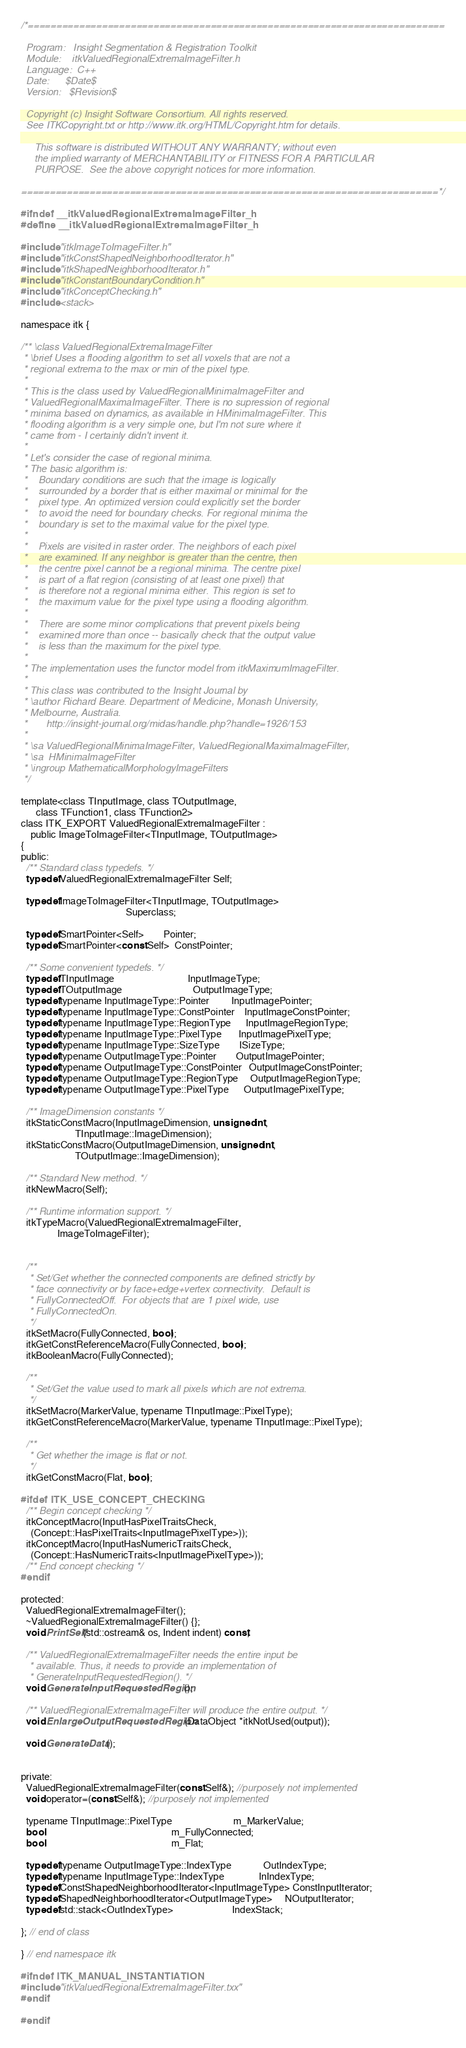<code> <loc_0><loc_0><loc_500><loc_500><_C_>/*=========================================================================

  Program:   Insight Segmentation & Registration Toolkit
  Module:    itkValuedRegionalExtremaImageFilter.h
  Language:  C++
  Date:      $Date$
  Version:   $Revision$

  Copyright (c) Insight Software Consortium. All rights reserved.
  See ITKCopyright.txt or http://www.itk.org/HTML/Copyright.htm for details.

     This software is distributed WITHOUT ANY WARRANTY; without even 
     the implied warranty of MERCHANTABILITY or FITNESS FOR A PARTICULAR 
     PURPOSE.  See the above copyright notices for more information.

=========================================================================*/

#ifndef __itkValuedRegionalExtremaImageFilter_h
#define __itkValuedRegionalExtremaImageFilter_h

#include "itkImageToImageFilter.h"
#include "itkConstShapedNeighborhoodIterator.h"
#include "itkShapedNeighborhoodIterator.h"
#include "itkConstantBoundaryCondition.h"
#include "itkConceptChecking.h"
#include <stack>

namespace itk {

/** \class ValuedRegionalExtremaImageFilter 
 * \brief Uses a flooding algorithm to set all voxels that are not a
 * regional extrema to the max or min of the pixel type. 
 *
 * This is the class used by ValuedRegionalMinimaImageFilter and
 * ValuedRegionalMaximaImageFilter. There is no supression of regional
 * minima based on dynamics, as available in HMinimaImageFilter. This
 * flooding algorithm is a very simple one, but I'm not sure where it
 * came from - I certainly didn't invent it.
 *
 * Let's consider the case of regional minima.
 * The basic algorithm is:
 *    Boundary conditions are such that the image is logically
 *    surrounded by a border that is either maximal or minimal for the
 *    pixel type. An optimized version could explicitly set the border
 *    to avoid the need for boundary checks. For regional minima the
 *    boundary is set to the maximal value for the pixel type.
 *
 *    Pixels are visited in raster order. The neighbors of each pixel
 *    are examined. If any neighbor is greater than the centre, then
 *    the centre pixel cannot be a regional minima. The centre pixel
 *    is part of a flat region (consisting of at least one pixel) that
 *    is therefore not a regional minima either. This region is set to
 *    the maximum value for the pixel type using a flooding algorithm.
 *
 *    There are some minor complications that prevent pixels being
 *    examined more than once -- basically check that the output value
 *    is less than the maximum for the pixel type.
 *
 * The implementation uses the functor model from itkMaximumImageFilter.
 * 
 * This class was contributed to the Insight Journal by 
 * \author Richard Beare. Department of Medicine, Monash University,
 * Melbourne, Australia.
 *       http://insight-journal.org/midas/handle.php?handle=1926/153 
 *
 * \sa ValuedRegionalMinimaImageFilter, ValuedRegionalMaximaImageFilter,
 * \sa  HMinimaImageFilter
 * \ingroup MathematicalMorphologyImageFilters
 */

template<class TInputImage, class TOutputImage, 
      class TFunction1, class TFunction2>
class ITK_EXPORT ValuedRegionalExtremaImageFilter : 
    public ImageToImageFilter<TInputImage, TOutputImage>
{
public:
  /** Standard class typedefs. */
  typedef ValuedRegionalExtremaImageFilter Self;

  typedef ImageToImageFilter<TInputImage, TOutputImage>
                                           Superclass;

  typedef SmartPointer<Self>        Pointer;
  typedef SmartPointer<const Self>  ConstPointer;

  /** Some convenient typedefs. */
  typedef TInputImage                              InputImageType;
  typedef TOutputImage                             OutputImageType;
  typedef typename InputImageType::Pointer         InputImagePointer;
  typedef typename InputImageType::ConstPointer    InputImageConstPointer;
  typedef typename InputImageType::RegionType      InputImageRegionType;
  typedef typename InputImageType::PixelType       InputImagePixelType;
  typedef typename InputImageType::SizeType        ISizeType;
  typedef typename OutputImageType::Pointer        OutputImagePointer;
  typedef typename OutputImageType::ConstPointer   OutputImageConstPointer;
  typedef typename OutputImageType::RegionType     OutputImageRegionType;
  typedef typename OutputImageType::PixelType      OutputImagePixelType;
  
  /** ImageDimension constants */
  itkStaticConstMacro(InputImageDimension, unsigned int,
                      TInputImage::ImageDimension);
  itkStaticConstMacro(OutputImageDimension, unsigned int,
                      TOutputImage::ImageDimension);

  /** Standard New method. */
  itkNewMacro(Self);  

  /** Runtime information support. */
  itkTypeMacro(ValuedRegionalExtremaImageFilter, 
               ImageToImageFilter);


  /**
   * Set/Get whether the connected components are defined strictly by
   * face connectivity or by face+edge+vertex connectivity.  Default is
   * FullyConnectedOff.  For objects that are 1 pixel wide, use
   * FullyConnectedOn.
   */
  itkSetMacro(FullyConnected, bool);
  itkGetConstReferenceMacro(FullyConnected, bool);
  itkBooleanMacro(FullyConnected);
  
  /**
   * Set/Get the value used to mark all pixels which are not extrema.
   */
  itkSetMacro(MarkerValue, typename TInputImage::PixelType);
  itkGetConstReferenceMacro(MarkerValue, typename TInputImage::PixelType);

  /**
   * Get whether the image is flat or not.
   */
  itkGetConstMacro(Flat, bool);

#ifdef ITK_USE_CONCEPT_CHECKING
  /** Begin concept checking */
  itkConceptMacro(InputHasPixelTraitsCheck,
    (Concept::HasPixelTraits<InputImagePixelType>));
  itkConceptMacro(InputHasNumericTraitsCheck,
    (Concept::HasNumericTraits<InputImagePixelType>));
  /** End concept checking */
#endif

protected:
  ValuedRegionalExtremaImageFilter();
  ~ValuedRegionalExtremaImageFilter() {};
  void PrintSelf(std::ostream& os, Indent indent) const;

  /** ValuedRegionalExtremaImageFilter needs the entire input be
   * available. Thus, it needs to provide an implementation of
   * GenerateInputRequestedRegion(). */
  void GenerateInputRequestedRegion();

  /** ValuedRegionalExtremaImageFilter will produce the entire output. */
  void EnlargeOutputRequestedRegion(DataObject *itkNotUsed(output));
  
  void GenerateData();
  

private:
  ValuedRegionalExtremaImageFilter(const Self&); //purposely not implemented
  void operator=(const Self&); //purposely not implemented

  typename TInputImage::PixelType                         m_MarkerValue;
  bool                                                    m_FullyConnected;
  bool                                                    m_Flat;

  typedef typename OutputImageType::IndexType             OutIndexType;
  typedef typename InputImageType::IndexType              InIndexType;
  typedef ConstShapedNeighborhoodIterator<InputImageType> ConstInputIterator;
  typedef ShapedNeighborhoodIterator<OutputImageType>     NOutputIterator;
  typedef std::stack<OutIndexType>                        IndexStack;

}; // end of class

} // end namespace itk
  
#ifndef ITK_MANUAL_INSTANTIATION
#include "itkValuedRegionalExtremaImageFilter.txx"
#endif

#endif
</code> 